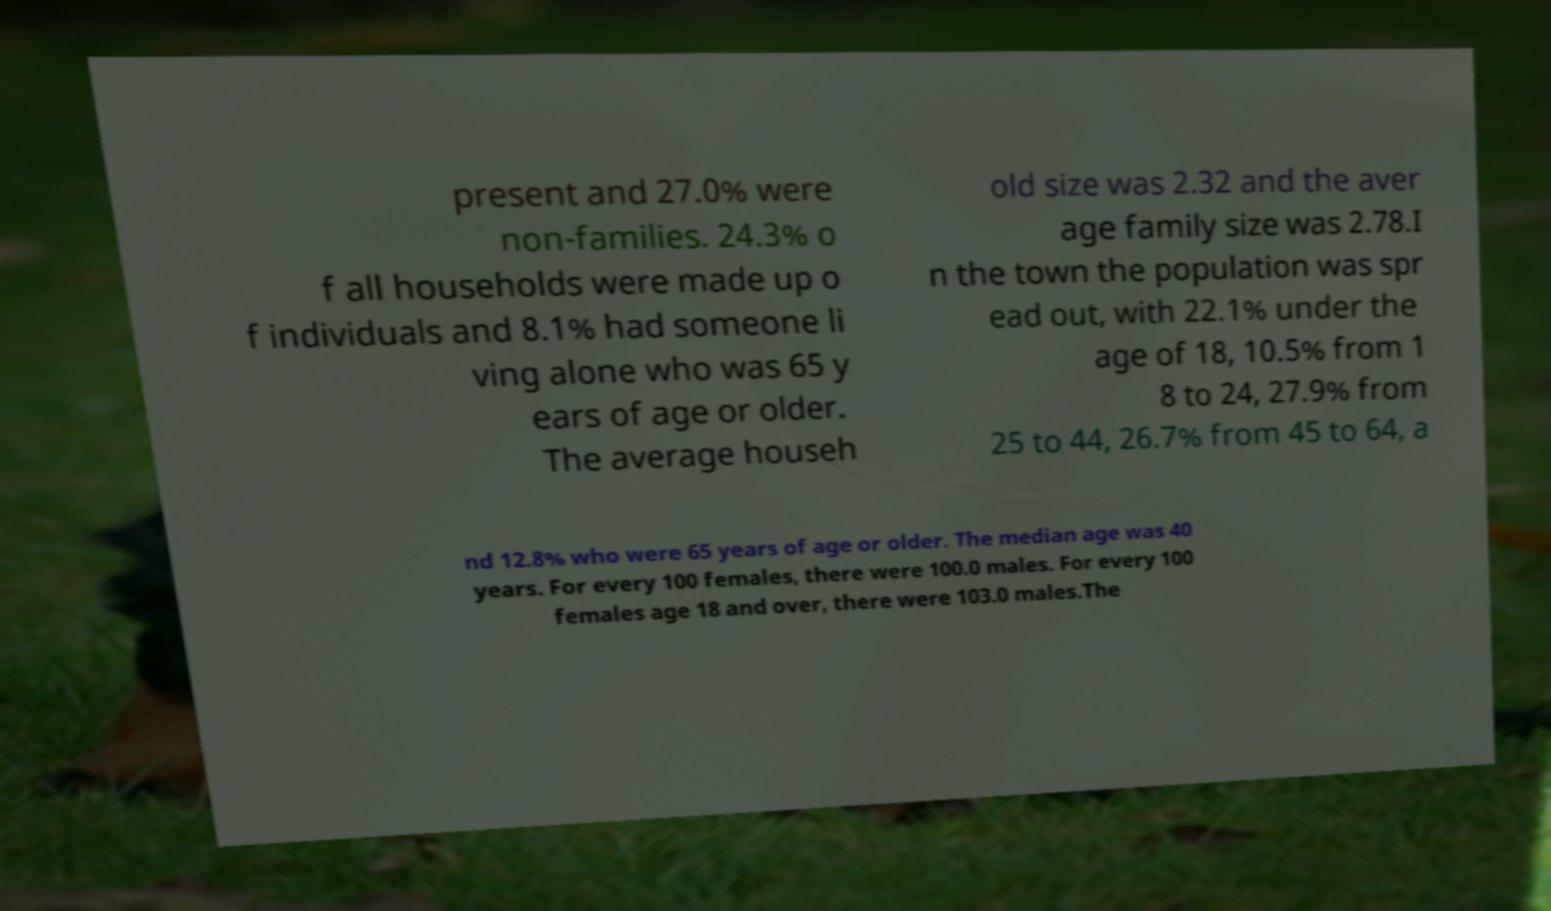Can you read and provide the text displayed in the image?This photo seems to have some interesting text. Can you extract and type it out for me? present and 27.0% were non-families. 24.3% o f all households were made up o f individuals and 8.1% had someone li ving alone who was 65 y ears of age or older. The average househ old size was 2.32 and the aver age family size was 2.78.I n the town the population was spr ead out, with 22.1% under the age of 18, 10.5% from 1 8 to 24, 27.9% from 25 to 44, 26.7% from 45 to 64, a nd 12.8% who were 65 years of age or older. The median age was 40 years. For every 100 females, there were 100.0 males. For every 100 females age 18 and over, there were 103.0 males.The 